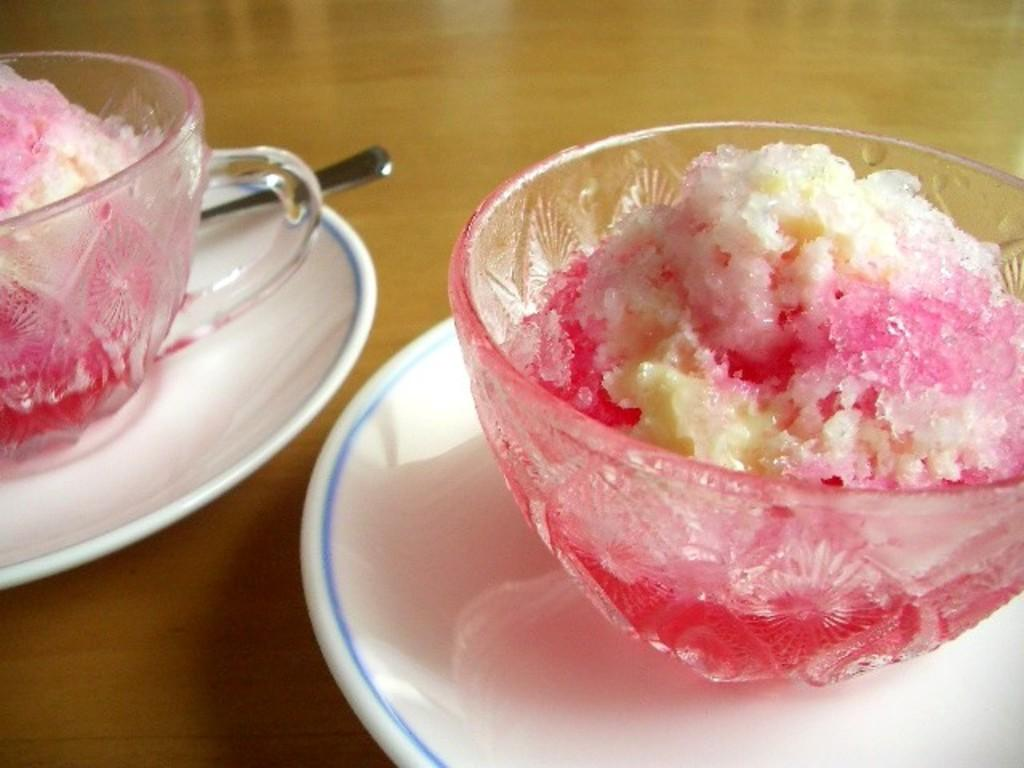What objects are in the foreground of the image? There are two plates in the foreground of the image. What is on each plate? Each plate has an ice cream bowl on it. Can you describe any utensils in the image? There is a spoon on the table. Where was the image taken? The image was taken in a room. How many legs can be seen on the cake in the image? There is no cake present in the image, so it is not possible to determine the number of legs on a cake. 